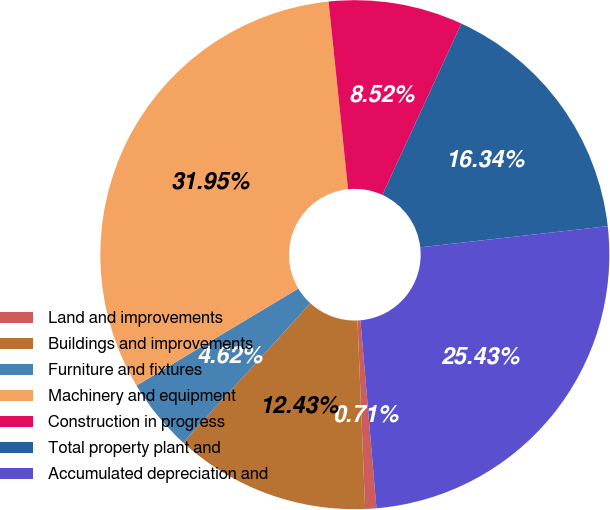<chart> <loc_0><loc_0><loc_500><loc_500><pie_chart><fcel>Land and improvements<fcel>Buildings and improvements<fcel>Furniture and fixtures<fcel>Machinery and equipment<fcel>Construction in progress<fcel>Total property plant and<fcel>Accumulated depreciation and<nl><fcel>0.71%<fcel>12.43%<fcel>4.62%<fcel>31.95%<fcel>8.52%<fcel>16.34%<fcel>25.43%<nl></chart> 